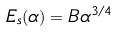<formula> <loc_0><loc_0><loc_500><loc_500>E _ { s } ( \alpha ) = B \alpha ^ { 3 / 4 }</formula> 